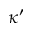Convert formula to latex. <formula><loc_0><loc_0><loc_500><loc_500>\kappa ^ { \prime }</formula> 